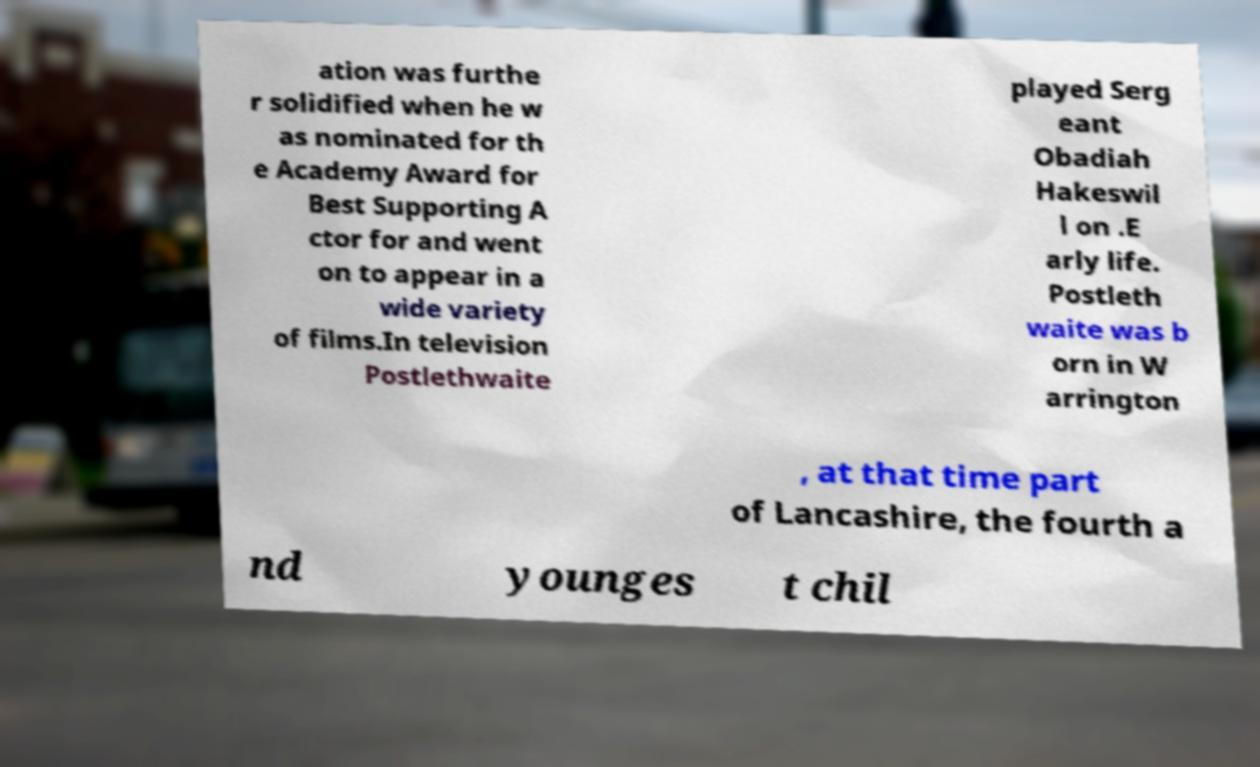Could you assist in decoding the text presented in this image and type it out clearly? ation was furthe r solidified when he w as nominated for th e Academy Award for Best Supporting A ctor for and went on to appear in a wide variety of films.In television Postlethwaite played Serg eant Obadiah Hakeswil l on .E arly life. Postleth waite was b orn in W arrington , at that time part of Lancashire, the fourth a nd younges t chil 